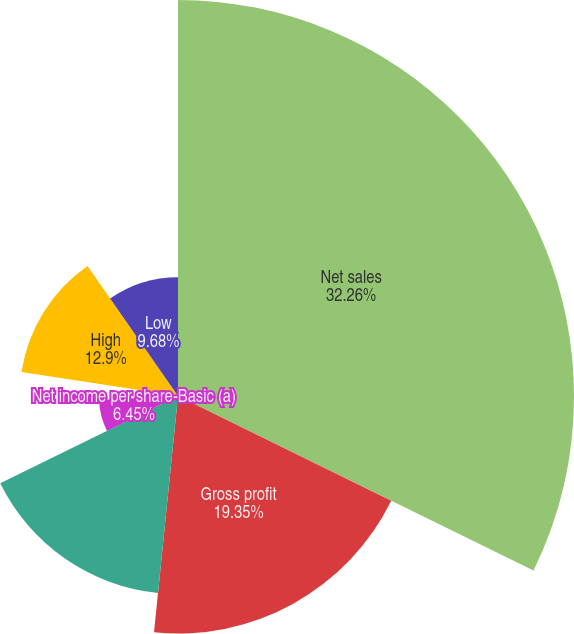<chart> <loc_0><loc_0><loc_500><loc_500><pie_chart><fcel>Net sales<fcel>Gross profit<fcel>Net income attributable to The<fcel>Net income per share-Basic (a)<fcel>Net income per share-Diluted<fcel>Dividends paid per share<fcel>High<fcel>Low<nl><fcel>32.26%<fcel>19.35%<fcel>16.13%<fcel>6.45%<fcel>3.23%<fcel>0.0%<fcel>12.9%<fcel>9.68%<nl></chart> 